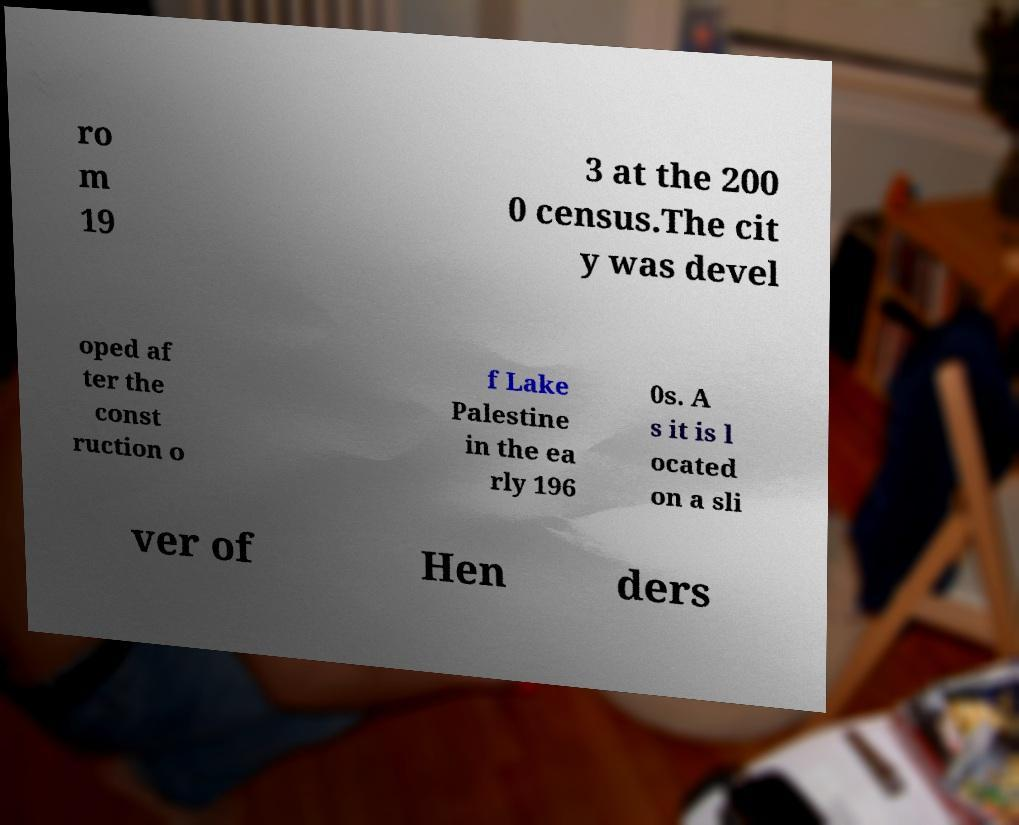I need the written content from this picture converted into text. Can you do that? ro m 19 3 at the 200 0 census.The cit y was devel oped af ter the const ruction o f Lake Palestine in the ea rly 196 0s. A s it is l ocated on a sli ver of Hen ders 